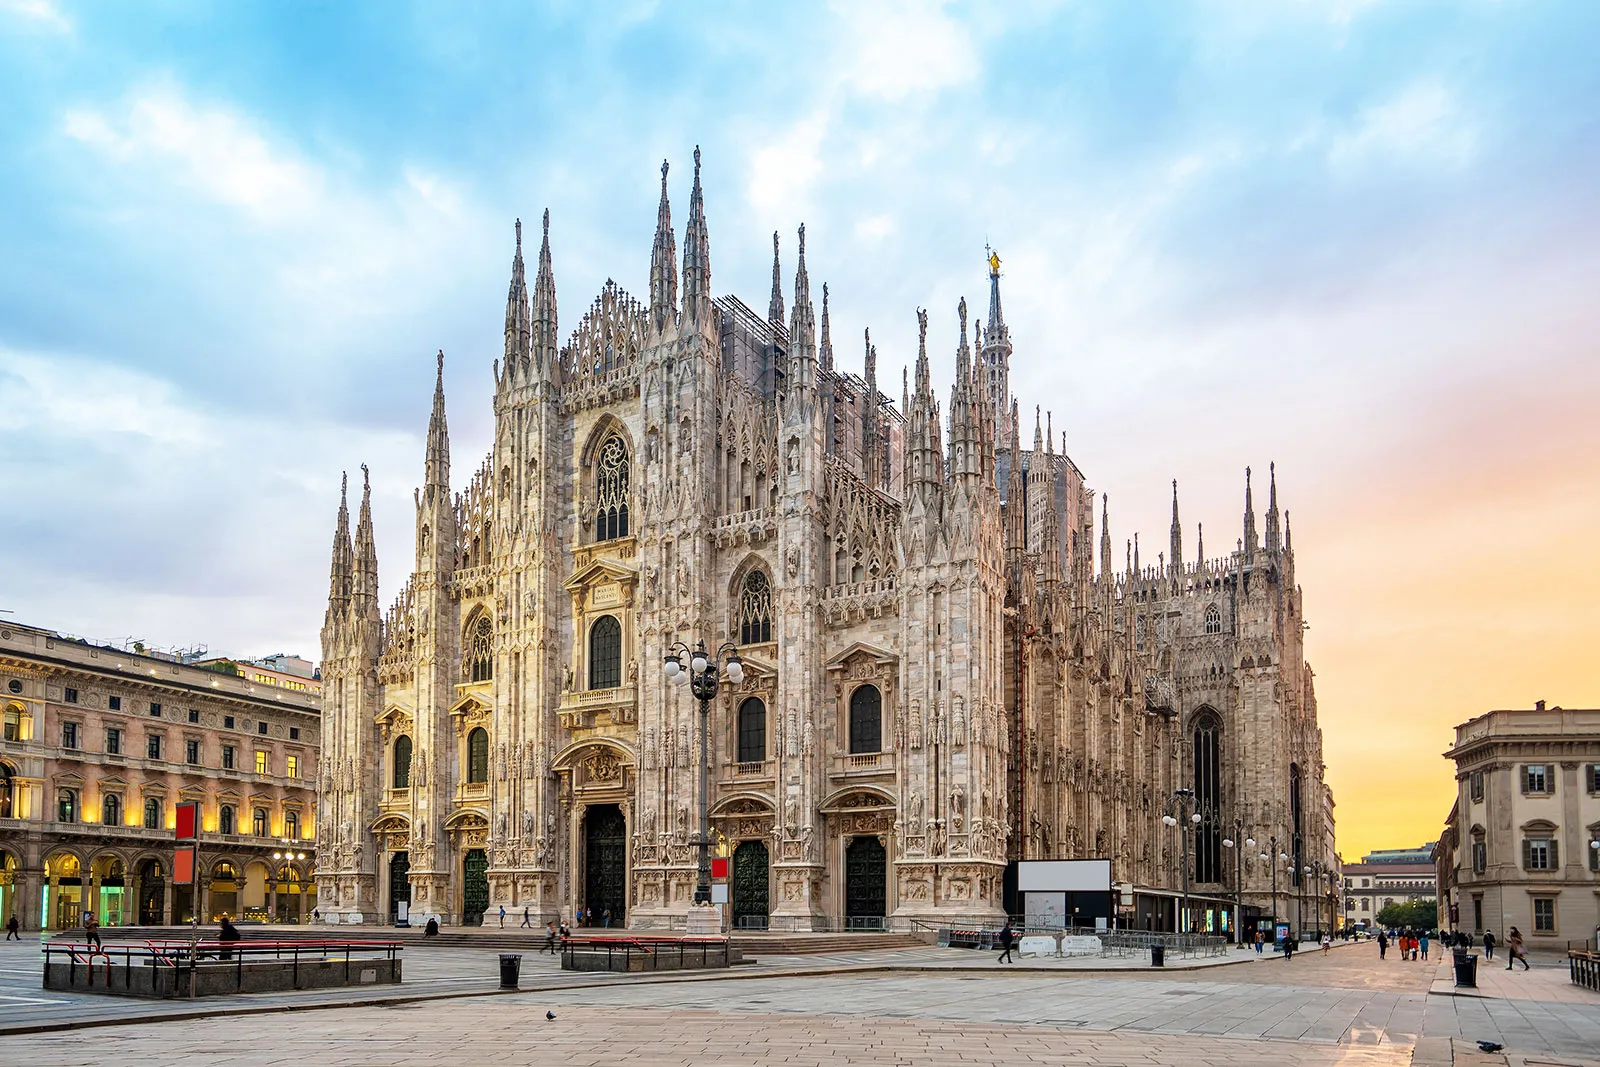How does the lighting in the image emphasize the architectural details of the cathedral? The lighting in the image, with hues of orange and blue from the sky, casts a soft glow on the Milan Cathedral, highlighting its intricate Gothic architectural details. The warm tones accentuate the white marble, creating shadows that define the spires and carvings, while the cool blue hues add depth to the structure. Is there any historical significance associated with the time of day this picture was taken? Photographs of the Milan Cathedral taken at sunrise or sunset may symbolize new beginnings or the passing of time, reflecting the enduring nature of this historical structure. These times of day enhance the beauty of the cathedral, emphasizing its historical and cultural significance against the backdrop of changing times. Imagine if the cathedral were a character in a fantasy story. What kind of personality and traits might it have? In a fantasy story, the Milan Cathedral could be depicted as a wise and noble character, ancient yet timeless, with a tranquil yet commanding presence. Its spires could symbolize aspirations and dreams, while its intricate carvings and details reflect a deep knowledge of history and culture. As a guardian of secrets and ancient wisdom, it would be revered and respected by all who encounter it. 